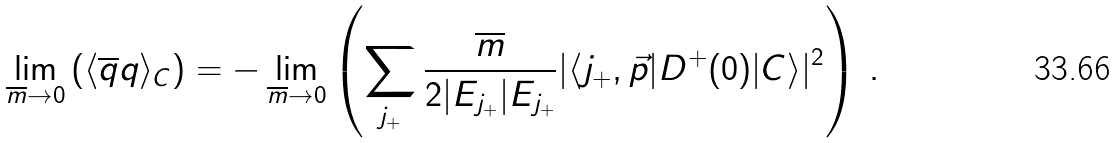<formula> <loc_0><loc_0><loc_500><loc_500>\lim _ { \overline { m } \to 0 } \left ( \langle \overline { q } q \rangle _ { C } \right ) = - \lim _ { \overline { m } \to 0 } \left ( \sum _ { j _ { + } } \frac { \overline { m } } { 2 | E _ { j _ { + } } | E _ { j _ { + } } } | \langle j _ { + } , \vec { p } | D ^ { + } ( 0 ) | C \rangle | ^ { 2 } \right ) \, .</formula> 